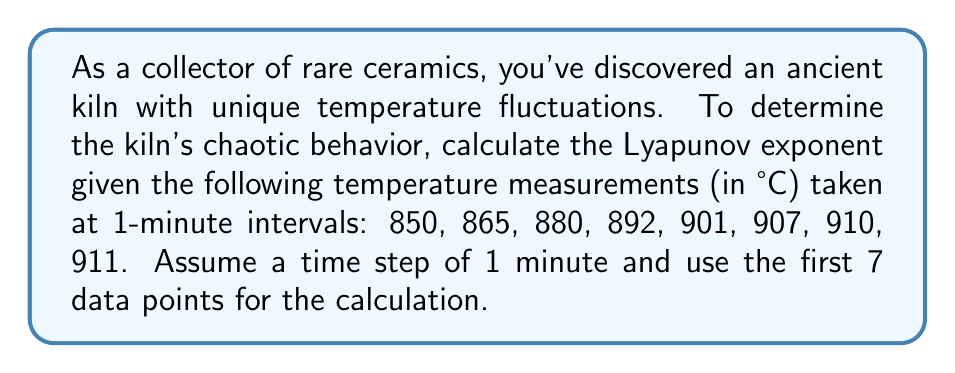Teach me how to tackle this problem. To calculate the Lyapunov exponent for the temperature variations in this ancient kiln, we'll follow these steps:

1) The Lyapunov exponent (λ) is given by:

   $$\lambda = \frac{1}{N} \sum_{i=1}^{N} \ln\left|\frac{x_{i+1} - x_i}{\Delta t}\right|$$

   where $N$ is the number of data points, $x_i$ are the temperature measurements, and $\Delta t$ is the time step.

2) We have 7 data points to use and $\Delta t = 1$ minute. Let's calculate each term:

   For i = 1: $\ln\left|\frac{865 - 850}{1}\right| = \ln(15) \approx 2.7081$
   For i = 2: $\ln\left|\frac{880 - 865}{1}\right| = \ln(15) \approx 2.7081$
   For i = 3: $\ln\left|\frac{892 - 880}{1}\right| = \ln(12) \approx 2.4849$
   For i = 4: $\ln\left|\frac{901 - 892}{1}\right| = \ln(9) \approx 2.1972$
   For i = 5: $\ln\left|\frac{907 - 901}{1}\right| = \ln(6) \approx 1.7918$
   For i = 6: $\ln\left|\frac{910 - 907}{1}\right| = \ln(3) \approx 1.0986$
   For i = 7: $\ln\left|\frac{911 - 910}{1}\right| = \ln(1) = 0$

3) Sum these values:

   $2.7081 + 2.7081 + 2.4849 + 2.1972 + 1.7918 + 1.0986 + 0 = 12.9887$

4) Divide by N (7) to get the Lyapunov exponent:

   $$\lambda = \frac{12.9887}{7} \approx 1.8555$$

A positive Lyapunov exponent indicates chaotic behavior in the kiln's temperature variations.
Answer: $\lambda \approx 1.8555$ 